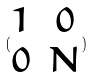<formula> <loc_0><loc_0><loc_500><loc_500>( \begin{matrix} 1 & 0 \\ 0 & N \end{matrix} )</formula> 